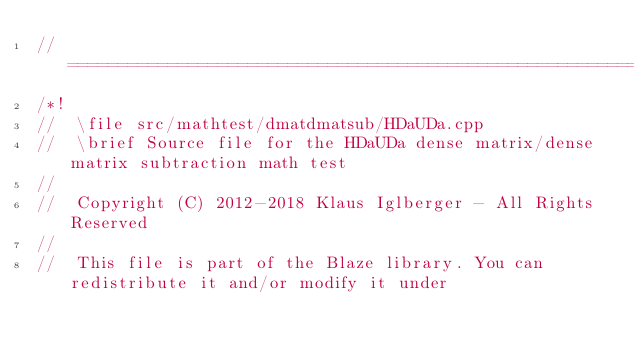Convert code to text. <code><loc_0><loc_0><loc_500><loc_500><_C++_>//=================================================================================================
/*!
//  \file src/mathtest/dmatdmatsub/HDaUDa.cpp
//  \brief Source file for the HDaUDa dense matrix/dense matrix subtraction math test
//
//  Copyright (C) 2012-2018 Klaus Iglberger - All Rights Reserved
//
//  This file is part of the Blaze library. You can redistribute it and/or modify it under</code> 